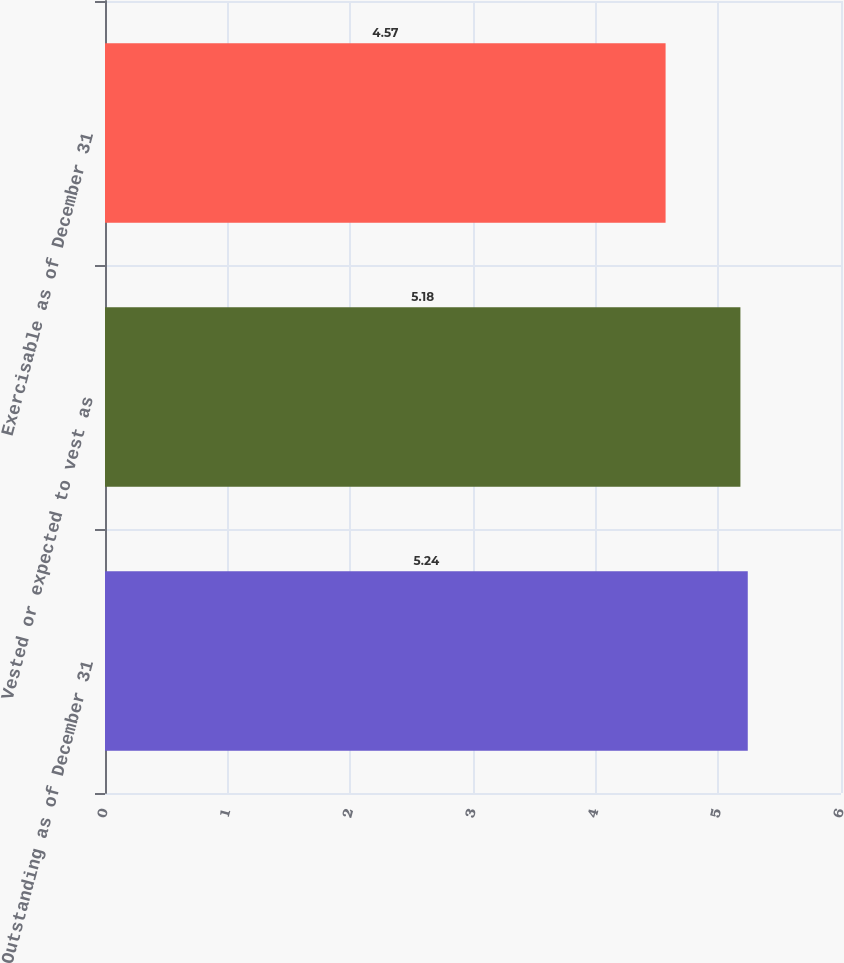Convert chart to OTSL. <chart><loc_0><loc_0><loc_500><loc_500><bar_chart><fcel>Outstanding as of December 31<fcel>Vested or expected to vest as<fcel>Exercisable as of December 31<nl><fcel>5.24<fcel>5.18<fcel>4.57<nl></chart> 